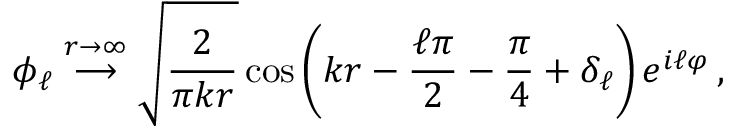<formula> <loc_0><loc_0><loc_500><loc_500>\phi _ { \ell } \stackrel { r \rightarrow \infty } { \longrightarrow } \sqrt { \frac { 2 } { \pi k r } } \cos \left ( k r - \frac { \ell \pi } { 2 } - \frac { \pi } { 4 } + \delta _ { \ell } \right ) e ^ { i \ell \varphi } \, ,</formula> 